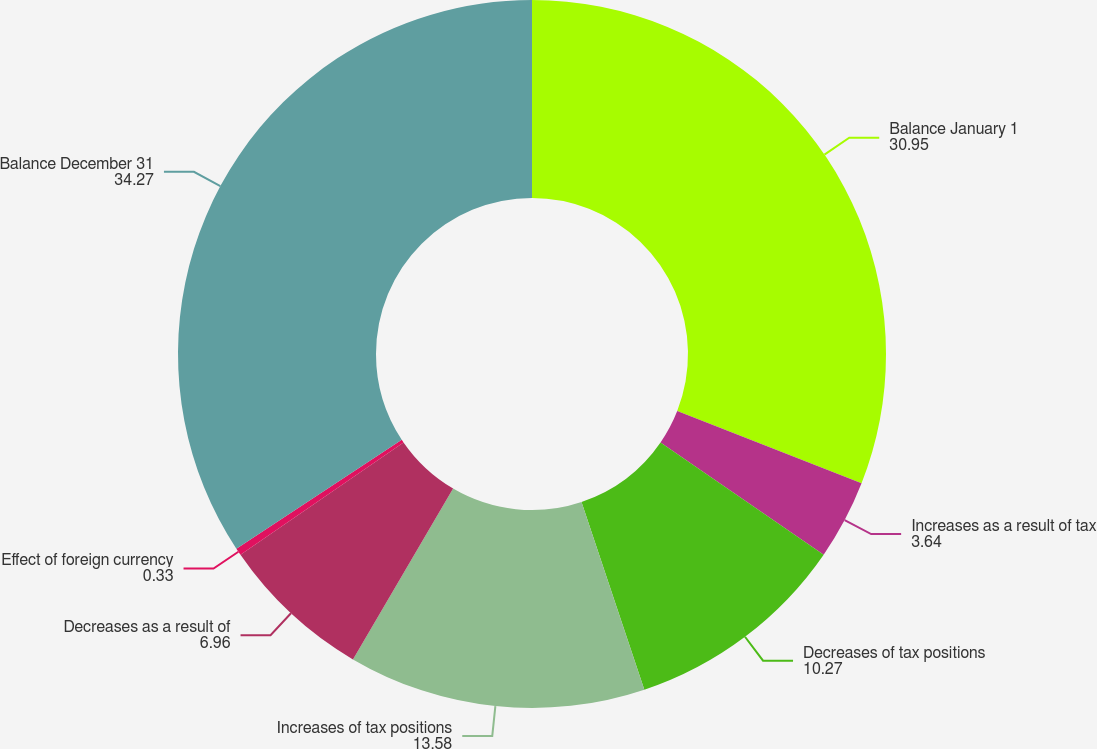Convert chart. <chart><loc_0><loc_0><loc_500><loc_500><pie_chart><fcel>Balance January 1<fcel>Increases as a result of tax<fcel>Decreases of tax positions<fcel>Increases of tax positions<fcel>Decreases as a result of<fcel>Effect of foreign currency<fcel>Balance December 31<nl><fcel>30.95%<fcel>3.64%<fcel>10.27%<fcel>13.58%<fcel>6.96%<fcel>0.33%<fcel>34.27%<nl></chart> 